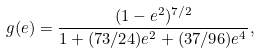Convert formula to latex. <formula><loc_0><loc_0><loc_500><loc_500>g ( e ) = \frac { ( 1 - e ^ { 2 } ) ^ { 7 / 2 } } { 1 + ( 7 3 / 2 4 ) e ^ { 2 } + ( 3 7 / 9 6 ) e ^ { 4 } } ,</formula> 